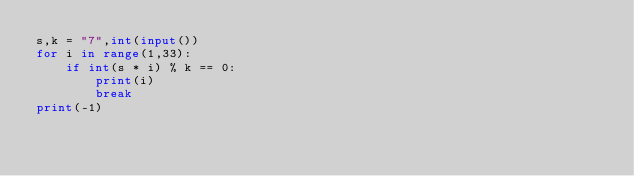Convert code to text. <code><loc_0><loc_0><loc_500><loc_500><_Python_>s,k = "7",int(input())
for i in range(1,33):
    if int(s * i) % k == 0:
        print(i)
        break
print(-1)</code> 